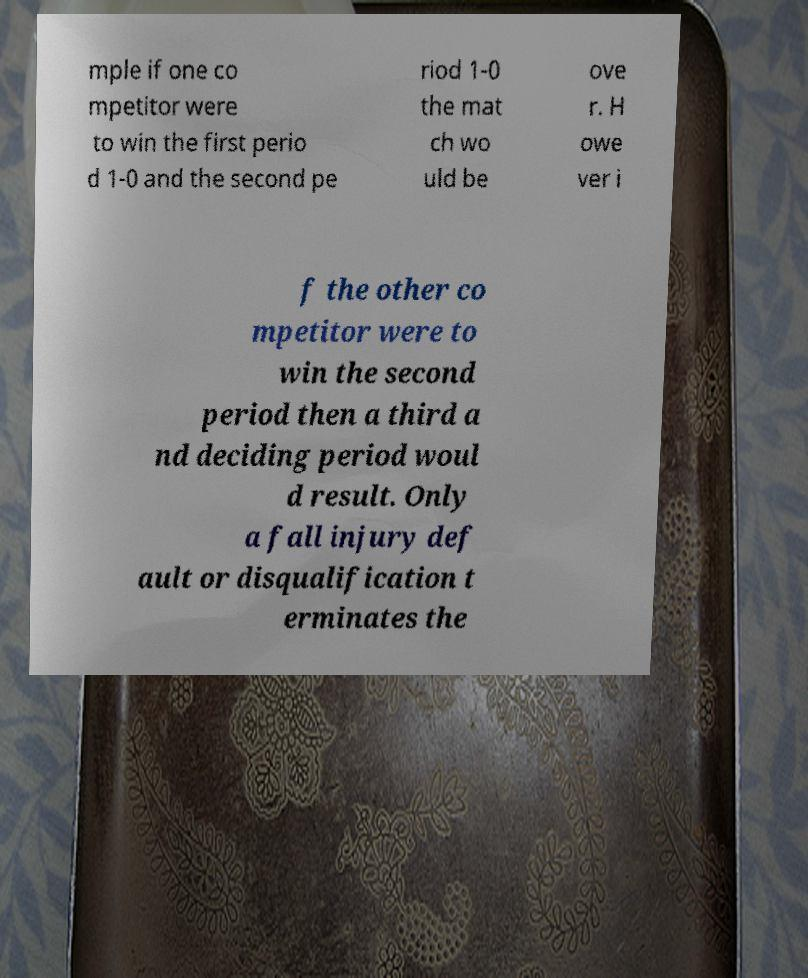Please read and relay the text visible in this image. What does it say? mple if one co mpetitor were to win the first perio d 1-0 and the second pe riod 1-0 the mat ch wo uld be ove r. H owe ver i f the other co mpetitor were to win the second period then a third a nd deciding period woul d result. Only a fall injury def ault or disqualification t erminates the 